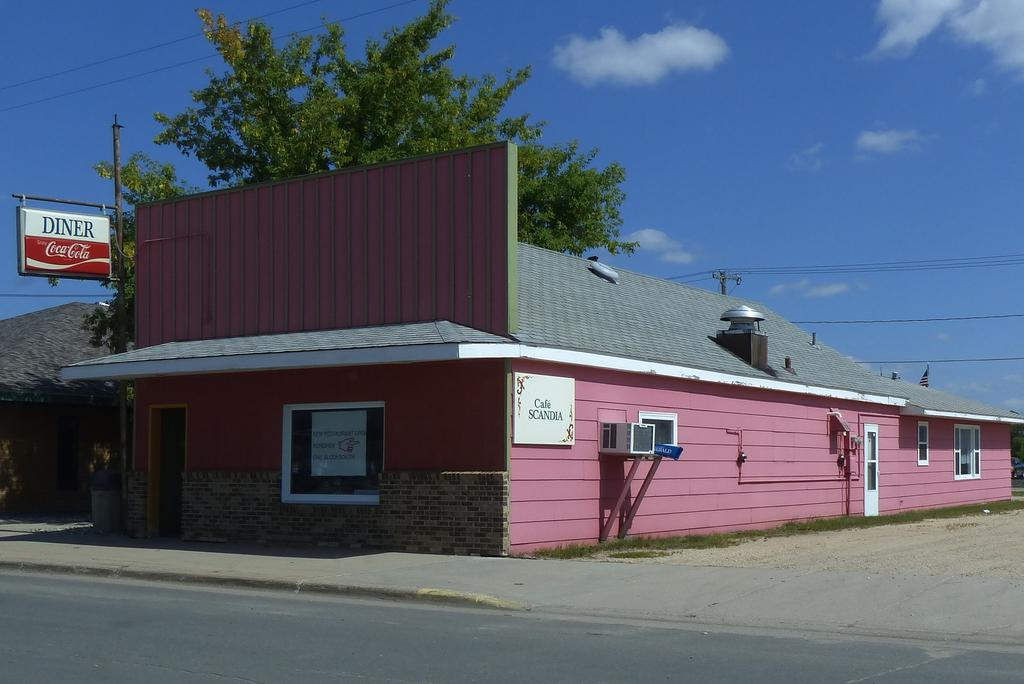What type of objects can be seen in the image? There are seeds, trees, boards, and wires visible in the image. What is located at the bottom of the image? There is a road at the bottom of the image. What can be seen in the background of the image? The sky is visible in the background of the image. What type of wine is being served at the event in the image? There is no event or wine present in the image; it features seeds, trees, boards, a road, and wires. 